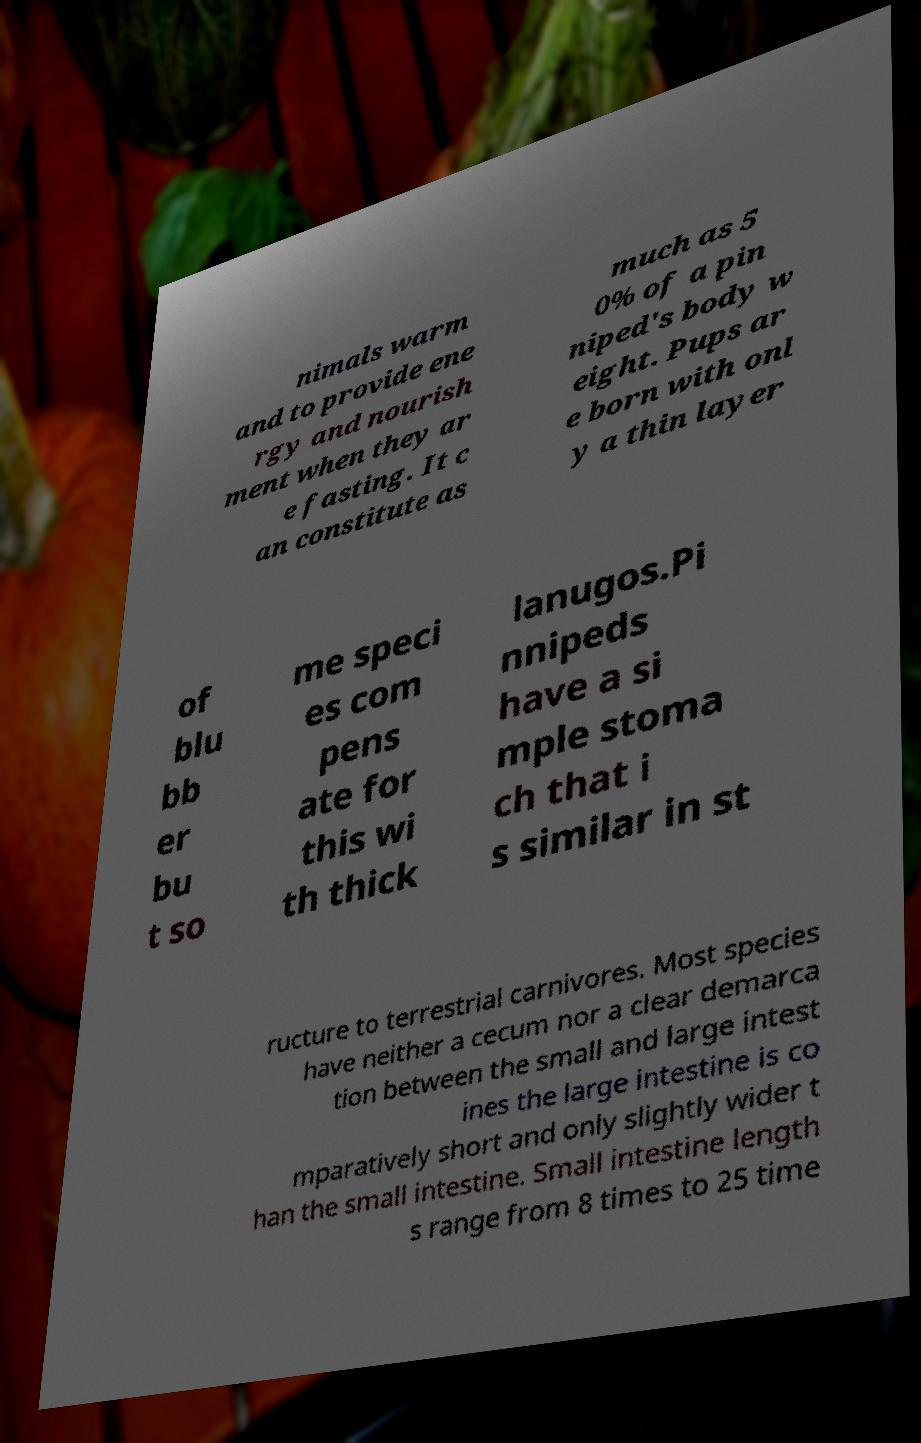I need the written content from this picture converted into text. Can you do that? nimals warm and to provide ene rgy and nourish ment when they ar e fasting. It c an constitute as much as 5 0% of a pin niped's body w eight. Pups ar e born with onl y a thin layer of blu bb er bu t so me speci es com pens ate for this wi th thick lanugos.Pi nnipeds have a si mple stoma ch that i s similar in st ructure to terrestrial carnivores. Most species have neither a cecum nor a clear demarca tion between the small and large intest ines the large intestine is co mparatively short and only slightly wider t han the small intestine. Small intestine length s range from 8 times to 25 time 